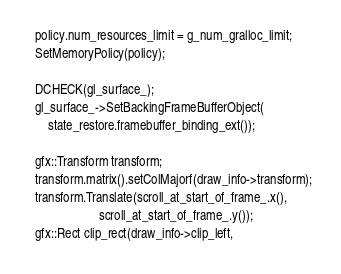Convert code to text. <code><loc_0><loc_0><loc_500><loc_500><_C++_>  policy.num_resources_limit = g_num_gralloc_limit;
  SetMemoryPolicy(policy);

  DCHECK(gl_surface_);
  gl_surface_->SetBackingFrameBufferObject(
      state_restore.framebuffer_binding_ext());

  gfx::Transform transform;
  transform.matrix().setColMajorf(draw_info->transform);
  transform.Translate(scroll_at_start_of_frame_.x(),
                      scroll_at_start_of_frame_.y());
  gfx::Rect clip_rect(draw_info->clip_left,</code> 